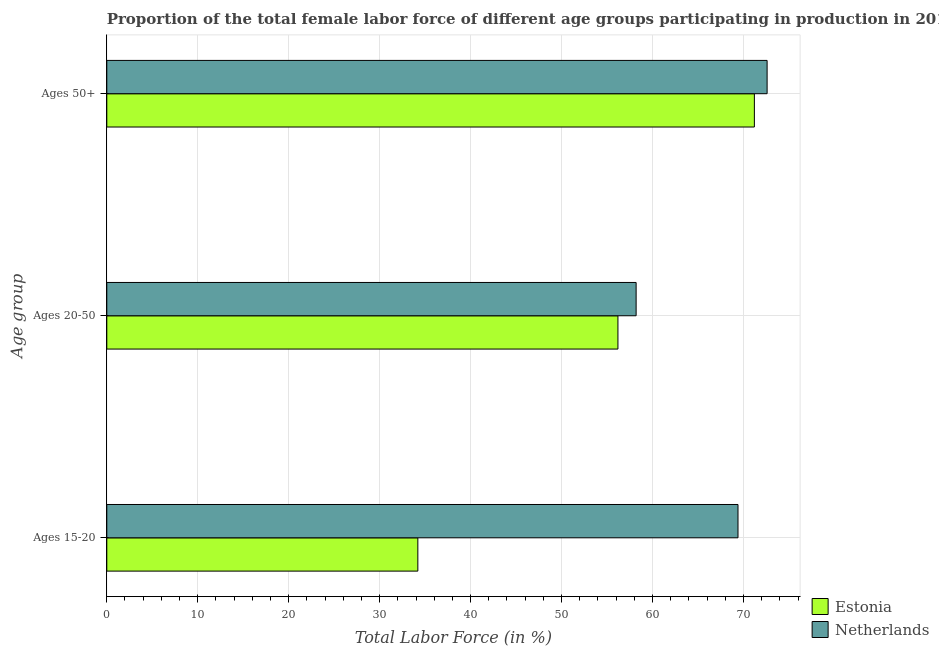How many different coloured bars are there?
Your answer should be very brief. 2. How many groups of bars are there?
Ensure brevity in your answer.  3. Are the number of bars per tick equal to the number of legend labels?
Offer a very short reply. Yes. Are the number of bars on each tick of the Y-axis equal?
Provide a short and direct response. Yes. How many bars are there on the 1st tick from the top?
Offer a terse response. 2. What is the label of the 1st group of bars from the top?
Your response must be concise. Ages 50+. What is the percentage of female labor force within the age group 15-20 in Estonia?
Your response must be concise. 34.2. Across all countries, what is the maximum percentage of female labor force above age 50?
Your answer should be compact. 72.6. Across all countries, what is the minimum percentage of female labor force above age 50?
Offer a terse response. 71.2. In which country was the percentage of female labor force within the age group 15-20 minimum?
Offer a terse response. Estonia. What is the total percentage of female labor force within the age group 20-50 in the graph?
Ensure brevity in your answer.  114.4. What is the difference between the percentage of female labor force above age 50 in Netherlands and the percentage of female labor force within the age group 15-20 in Estonia?
Your answer should be compact. 38.4. What is the average percentage of female labor force within the age group 15-20 per country?
Offer a very short reply. 51.8. What is the difference between the percentage of female labor force within the age group 15-20 and percentage of female labor force above age 50 in Netherlands?
Offer a terse response. -3.2. In how many countries, is the percentage of female labor force within the age group 15-20 greater than 40 %?
Your response must be concise. 1. What is the ratio of the percentage of female labor force above age 50 in Estonia to that in Netherlands?
Ensure brevity in your answer.  0.98. Is the percentage of female labor force above age 50 in Netherlands less than that in Estonia?
Make the answer very short. No. Is the difference between the percentage of female labor force within the age group 20-50 in Estonia and Netherlands greater than the difference between the percentage of female labor force above age 50 in Estonia and Netherlands?
Provide a succinct answer. No. What is the difference between the highest and the second highest percentage of female labor force above age 50?
Your answer should be very brief. 1.4. What is the difference between the highest and the lowest percentage of female labor force above age 50?
Your response must be concise. 1.4. In how many countries, is the percentage of female labor force above age 50 greater than the average percentage of female labor force above age 50 taken over all countries?
Keep it short and to the point. 1. Is the sum of the percentage of female labor force above age 50 in Estonia and Netherlands greater than the maximum percentage of female labor force within the age group 15-20 across all countries?
Offer a very short reply. Yes. What does the 2nd bar from the top in Ages 20-50 represents?
Provide a short and direct response. Estonia. What does the 2nd bar from the bottom in Ages 15-20 represents?
Provide a short and direct response. Netherlands. Is it the case that in every country, the sum of the percentage of female labor force within the age group 15-20 and percentage of female labor force within the age group 20-50 is greater than the percentage of female labor force above age 50?
Ensure brevity in your answer.  Yes. How many bars are there?
Offer a terse response. 6. Are all the bars in the graph horizontal?
Your response must be concise. Yes. How many countries are there in the graph?
Offer a terse response. 2. Does the graph contain any zero values?
Your answer should be very brief. No. Does the graph contain grids?
Keep it short and to the point. Yes. What is the title of the graph?
Offer a terse response. Proportion of the total female labor force of different age groups participating in production in 2010. What is the label or title of the X-axis?
Make the answer very short. Total Labor Force (in %). What is the label or title of the Y-axis?
Provide a short and direct response. Age group. What is the Total Labor Force (in %) of Estonia in Ages 15-20?
Ensure brevity in your answer.  34.2. What is the Total Labor Force (in %) of Netherlands in Ages 15-20?
Make the answer very short. 69.4. What is the Total Labor Force (in %) in Estonia in Ages 20-50?
Offer a very short reply. 56.2. What is the Total Labor Force (in %) of Netherlands in Ages 20-50?
Your answer should be very brief. 58.2. What is the Total Labor Force (in %) of Estonia in Ages 50+?
Offer a terse response. 71.2. What is the Total Labor Force (in %) in Netherlands in Ages 50+?
Your answer should be very brief. 72.6. Across all Age group, what is the maximum Total Labor Force (in %) of Estonia?
Offer a very short reply. 71.2. Across all Age group, what is the maximum Total Labor Force (in %) of Netherlands?
Ensure brevity in your answer.  72.6. Across all Age group, what is the minimum Total Labor Force (in %) of Estonia?
Offer a very short reply. 34.2. Across all Age group, what is the minimum Total Labor Force (in %) in Netherlands?
Make the answer very short. 58.2. What is the total Total Labor Force (in %) of Estonia in the graph?
Keep it short and to the point. 161.6. What is the total Total Labor Force (in %) of Netherlands in the graph?
Offer a terse response. 200.2. What is the difference between the Total Labor Force (in %) of Estonia in Ages 15-20 and that in Ages 20-50?
Your answer should be compact. -22. What is the difference between the Total Labor Force (in %) of Netherlands in Ages 15-20 and that in Ages 20-50?
Provide a succinct answer. 11.2. What is the difference between the Total Labor Force (in %) of Estonia in Ages 15-20 and that in Ages 50+?
Give a very brief answer. -37. What is the difference between the Total Labor Force (in %) of Netherlands in Ages 15-20 and that in Ages 50+?
Offer a very short reply. -3.2. What is the difference between the Total Labor Force (in %) in Netherlands in Ages 20-50 and that in Ages 50+?
Your answer should be very brief. -14.4. What is the difference between the Total Labor Force (in %) of Estonia in Ages 15-20 and the Total Labor Force (in %) of Netherlands in Ages 20-50?
Offer a terse response. -24. What is the difference between the Total Labor Force (in %) in Estonia in Ages 15-20 and the Total Labor Force (in %) in Netherlands in Ages 50+?
Your response must be concise. -38.4. What is the difference between the Total Labor Force (in %) of Estonia in Ages 20-50 and the Total Labor Force (in %) of Netherlands in Ages 50+?
Provide a short and direct response. -16.4. What is the average Total Labor Force (in %) of Estonia per Age group?
Give a very brief answer. 53.87. What is the average Total Labor Force (in %) of Netherlands per Age group?
Your answer should be very brief. 66.73. What is the difference between the Total Labor Force (in %) in Estonia and Total Labor Force (in %) in Netherlands in Ages 15-20?
Give a very brief answer. -35.2. What is the difference between the Total Labor Force (in %) of Estonia and Total Labor Force (in %) of Netherlands in Ages 50+?
Your response must be concise. -1.4. What is the ratio of the Total Labor Force (in %) of Estonia in Ages 15-20 to that in Ages 20-50?
Your response must be concise. 0.61. What is the ratio of the Total Labor Force (in %) of Netherlands in Ages 15-20 to that in Ages 20-50?
Offer a very short reply. 1.19. What is the ratio of the Total Labor Force (in %) in Estonia in Ages 15-20 to that in Ages 50+?
Offer a terse response. 0.48. What is the ratio of the Total Labor Force (in %) in Netherlands in Ages 15-20 to that in Ages 50+?
Ensure brevity in your answer.  0.96. What is the ratio of the Total Labor Force (in %) of Estonia in Ages 20-50 to that in Ages 50+?
Ensure brevity in your answer.  0.79. What is the ratio of the Total Labor Force (in %) of Netherlands in Ages 20-50 to that in Ages 50+?
Keep it short and to the point. 0.8. 